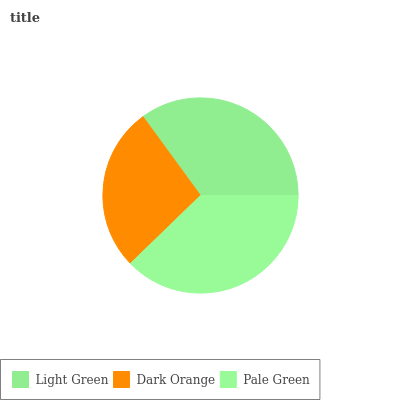Is Dark Orange the minimum?
Answer yes or no. Yes. Is Pale Green the maximum?
Answer yes or no. Yes. Is Pale Green the minimum?
Answer yes or no. No. Is Dark Orange the maximum?
Answer yes or no. No. Is Pale Green greater than Dark Orange?
Answer yes or no. Yes. Is Dark Orange less than Pale Green?
Answer yes or no. Yes. Is Dark Orange greater than Pale Green?
Answer yes or no. No. Is Pale Green less than Dark Orange?
Answer yes or no. No. Is Light Green the high median?
Answer yes or no. Yes. Is Light Green the low median?
Answer yes or no. Yes. Is Dark Orange the high median?
Answer yes or no. No. Is Dark Orange the low median?
Answer yes or no. No. 